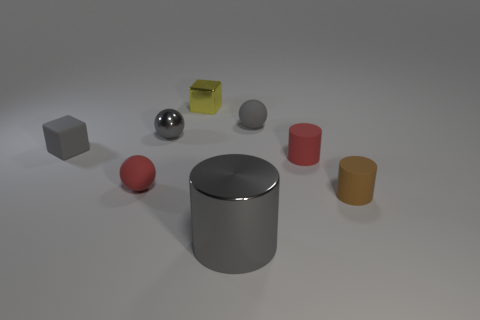There is a ball that is to the right of the metallic cylinder; is it the same color as the big metal object?
Your response must be concise. Yes. How many other things are there of the same shape as the small brown object?
Your answer should be compact. 2. How many other objects are there of the same material as the gray cylinder?
Keep it short and to the point. 2. There is a block behind the gray rubber block behind the tiny red thing right of the small gray rubber ball; what is it made of?
Offer a terse response. Metal. Is the material of the brown thing the same as the tiny red sphere?
Provide a short and direct response. Yes. What number of balls are either big cyan rubber objects or tiny yellow metallic objects?
Provide a succinct answer. 0. The tiny rubber ball right of the tiny yellow cube is what color?
Your response must be concise. Gray. How many rubber objects are either small gray objects or balls?
Offer a very short reply. 3. There is a red thing that is left of the sphere on the right side of the yellow metallic thing; what is it made of?
Keep it short and to the point. Rubber. What is the material of the big cylinder that is the same color as the small metal ball?
Provide a short and direct response. Metal. 